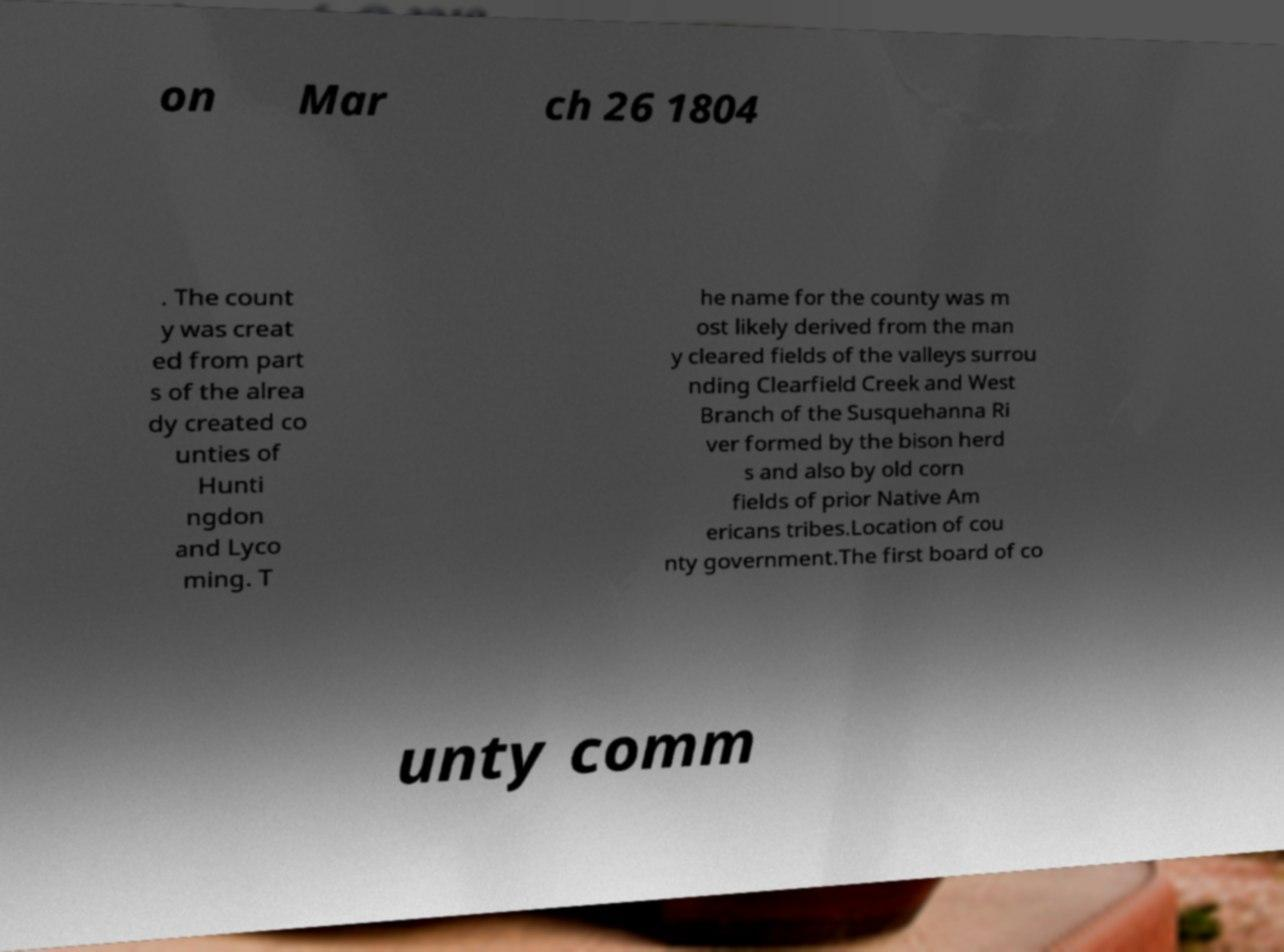For documentation purposes, I need the text within this image transcribed. Could you provide that? on Mar ch 26 1804 . The count y was creat ed from part s of the alrea dy created co unties of Hunti ngdon and Lyco ming. T he name for the county was m ost likely derived from the man y cleared fields of the valleys surrou nding Clearfield Creek and West Branch of the Susquehanna Ri ver formed by the bison herd s and also by old corn fields of prior Native Am ericans tribes.Location of cou nty government.The first board of co unty comm 